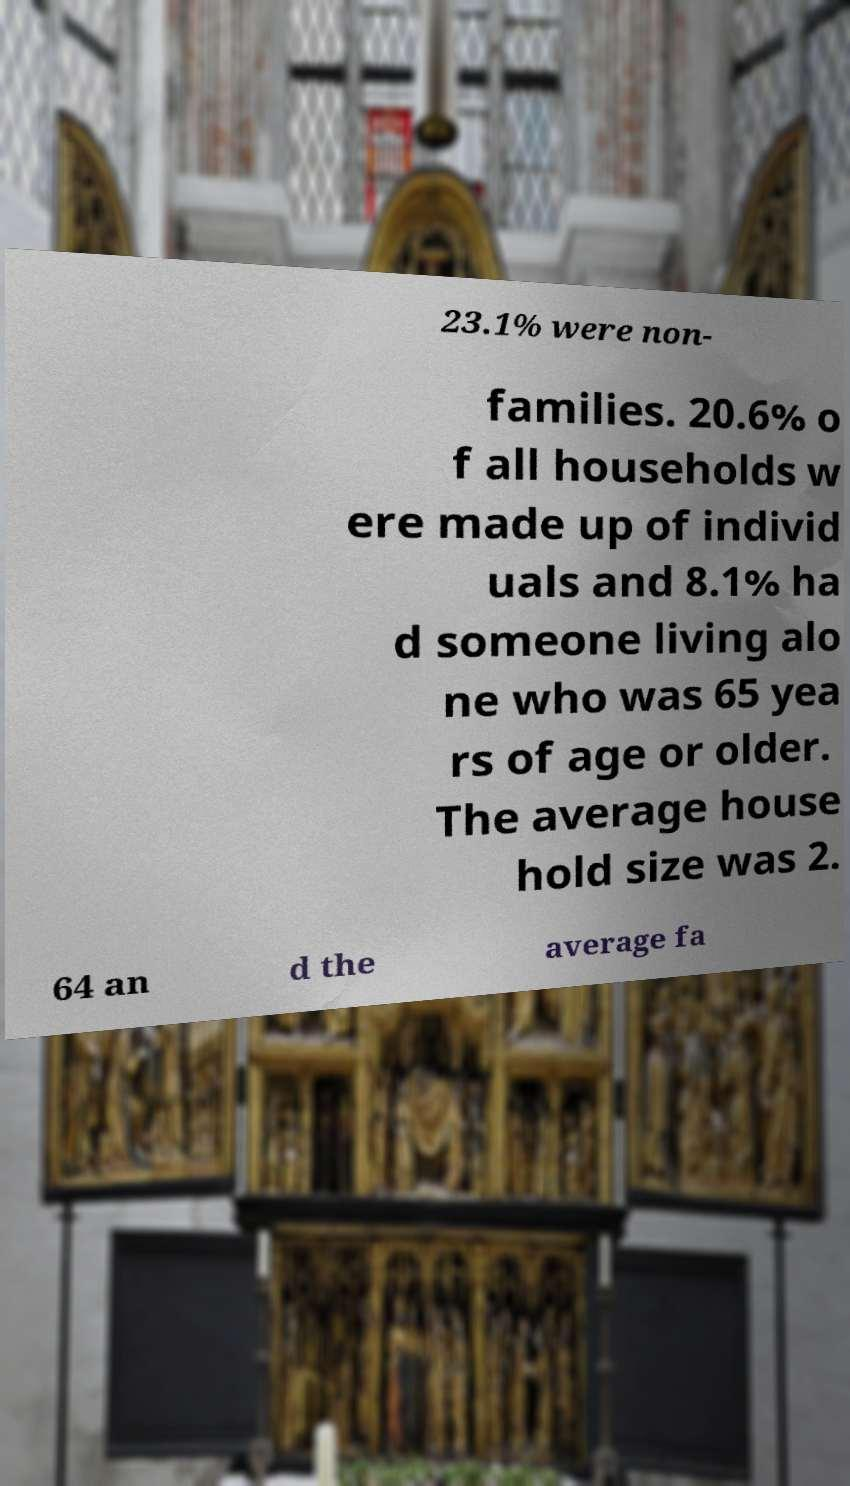Please read and relay the text visible in this image. What does it say? 23.1% were non- families. 20.6% o f all households w ere made up of individ uals and 8.1% ha d someone living alo ne who was 65 yea rs of age or older. The average house hold size was 2. 64 an d the average fa 